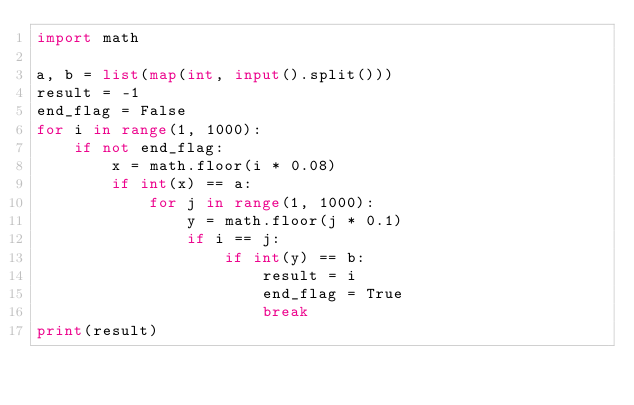<code> <loc_0><loc_0><loc_500><loc_500><_Python_>import math

a, b = list(map(int, input().split()))
result = -1
end_flag = False
for i in range(1, 1000):
    if not end_flag:
        x = math.floor(i * 0.08)
        if int(x) == a:
            for j in range(1, 1000):
                y = math.floor(j * 0.1)
                if i == j:
                    if int(y) == b:
                        result = i
                        end_flag = True
                        break
print(result)
</code> 